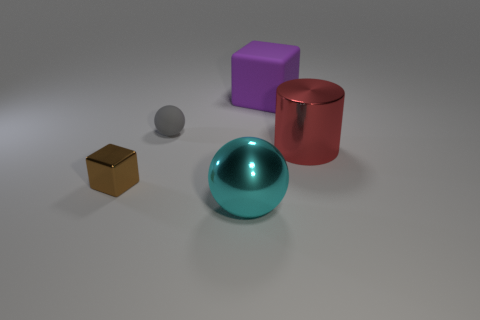There is a object behind the tiny rubber thing; does it have the same size as the metallic object that is to the right of the big sphere?
Your answer should be very brief. Yes. What number of red things are the same material as the large purple object?
Your answer should be compact. 0. The big shiny cylinder has what color?
Make the answer very short. Red. There is a red cylinder; are there any big cyan shiny balls on the right side of it?
Offer a very short reply. No. Does the tiny shiny thing have the same color as the small ball?
Ensure brevity in your answer.  No. What size is the object in front of the small thing that is in front of the red thing?
Your answer should be very brief. Large. There is a big purple matte object; what shape is it?
Offer a very short reply. Cube. What is the material of the ball behind the cyan metal sphere?
Ensure brevity in your answer.  Rubber. The rubber object in front of the matte thing that is on the right side of the sphere behind the large cyan sphere is what color?
Make the answer very short. Gray. The shiny cylinder that is the same size as the purple object is what color?
Your answer should be compact. Red. 